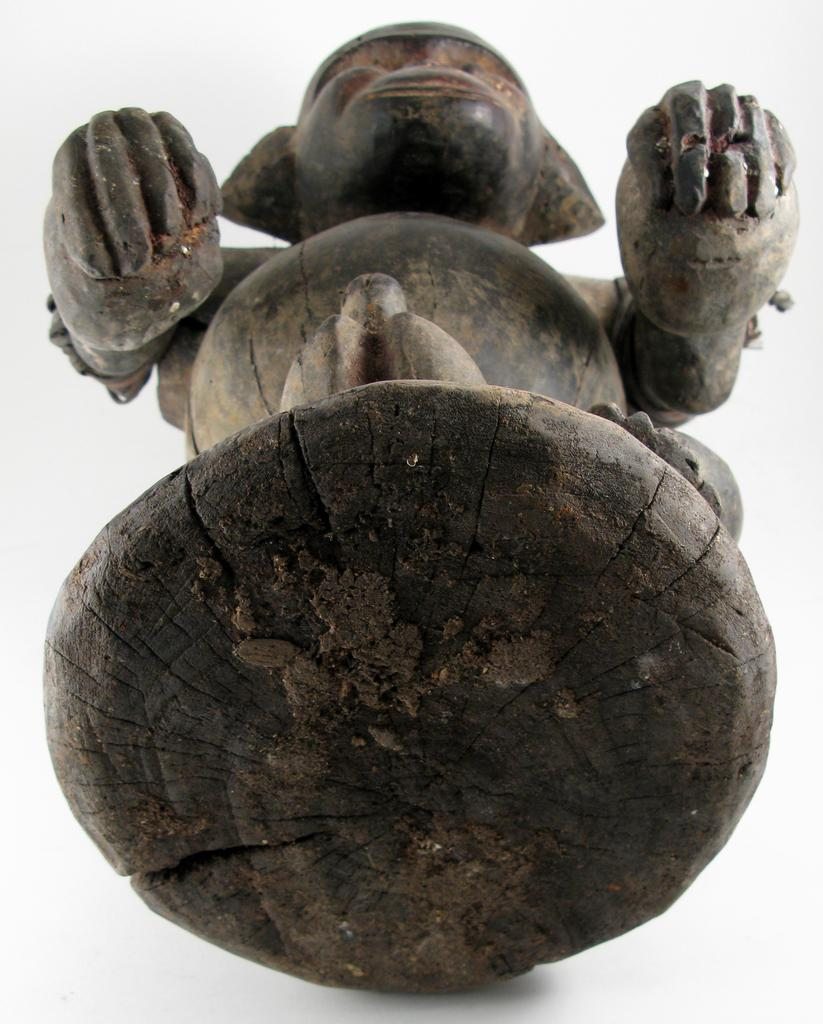What is the main subject in the center of the image? There is a sculpture in the center of the image. What type of trousers can be seen on the sculpture in the image? There are no trousers present on the sculpture in the image. What is the sculpture using to control the movement of the train in the image? There is no train or whip present in the image; it features a sculpture. 